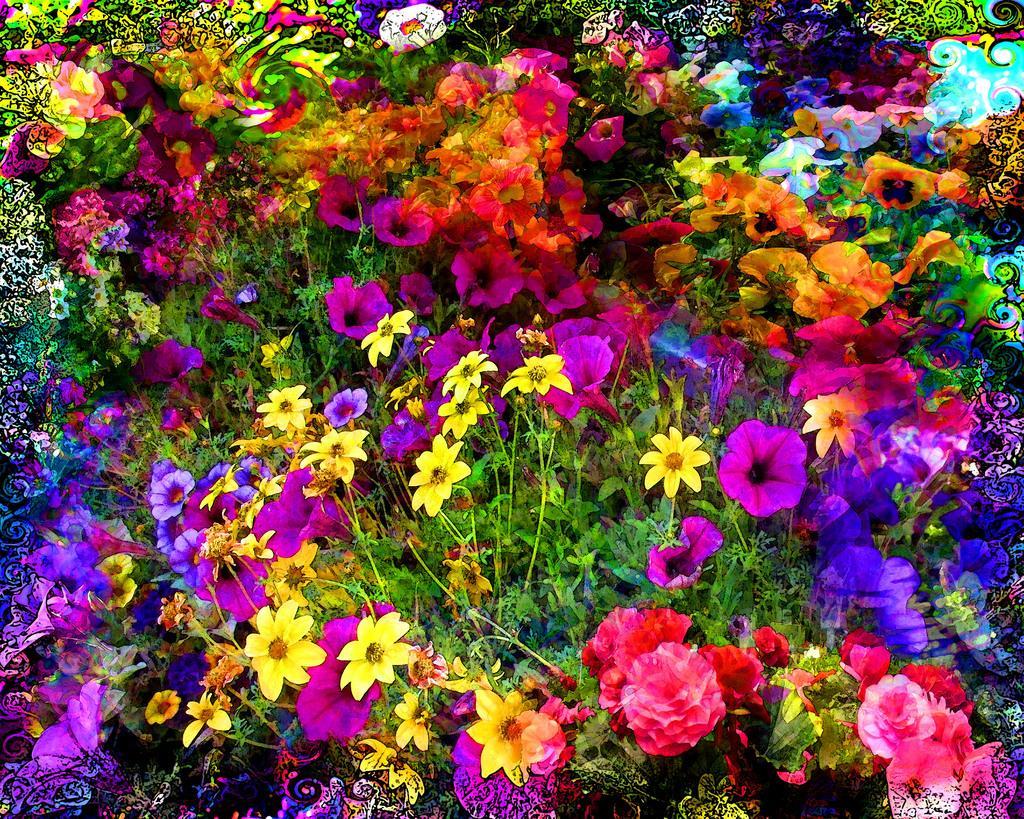Can you describe this image briefly? In the picture we can see a group of plants to the flowers and the flowers are red, pink, yellow, violet, blue in color. 